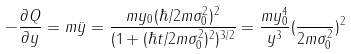<formula> <loc_0><loc_0><loc_500><loc_500>- \frac { \partial Q } { \partial y } = m \ddot { y } = \frac { m y _ { 0 } ( \hbar { / } 2 m \sigma _ { 0 } ^ { 2 } ) ^ { 2 } } { ( 1 + ( \hbar { t } / 2 m \sigma _ { 0 } ^ { 2 } ) ^ { 2 } ) ^ { 3 / 2 } } = \frac { m y _ { 0 } ^ { 4 } } { y ^ { 3 } } ( \frac { } { 2 m \sigma _ { 0 } ^ { 2 } } ) ^ { 2 }</formula> 